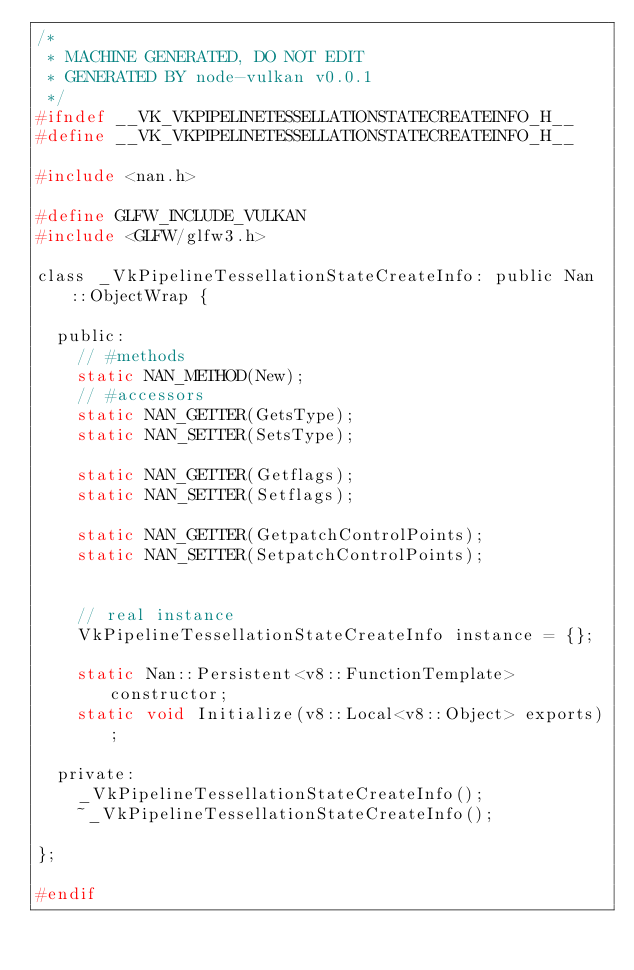Convert code to text. <code><loc_0><loc_0><loc_500><loc_500><_C_>/*
 * MACHINE GENERATED, DO NOT EDIT
 * GENERATED BY node-vulkan v0.0.1
 */
#ifndef __VK_VKPIPELINETESSELLATIONSTATECREATEINFO_H__
#define __VK_VKPIPELINETESSELLATIONSTATECREATEINFO_H__

#include <nan.h>

#define GLFW_INCLUDE_VULKAN
#include <GLFW/glfw3.h>

class _VkPipelineTessellationStateCreateInfo: public Nan::ObjectWrap {

  public:
    // #methods
    static NAN_METHOD(New);
    // #accessors
    static NAN_GETTER(GetsType);
    static NAN_SETTER(SetsType);
    
    static NAN_GETTER(Getflags);
    static NAN_SETTER(Setflags);
    
    static NAN_GETTER(GetpatchControlPoints);
    static NAN_SETTER(SetpatchControlPoints);
    

    // real instance
    VkPipelineTessellationStateCreateInfo instance = {};

    static Nan::Persistent<v8::FunctionTemplate> constructor;
    static void Initialize(v8::Local<v8::Object> exports);

  private:
    _VkPipelineTessellationStateCreateInfo();
    ~_VkPipelineTessellationStateCreateInfo();

};

#endif</code> 